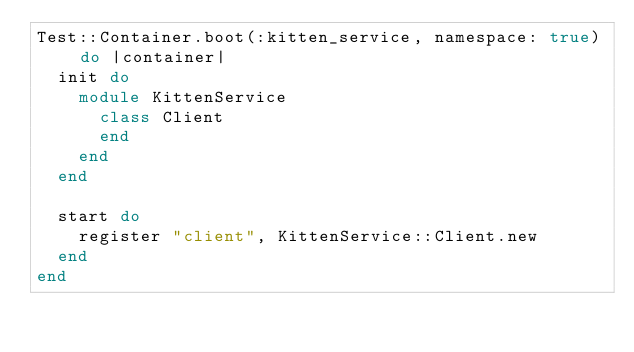<code> <loc_0><loc_0><loc_500><loc_500><_Ruby_>Test::Container.boot(:kitten_service, namespace: true) do |container|
  init do
    module KittenService
      class Client
      end
    end
  end

  start do
    register "client", KittenService::Client.new
  end
end
</code> 